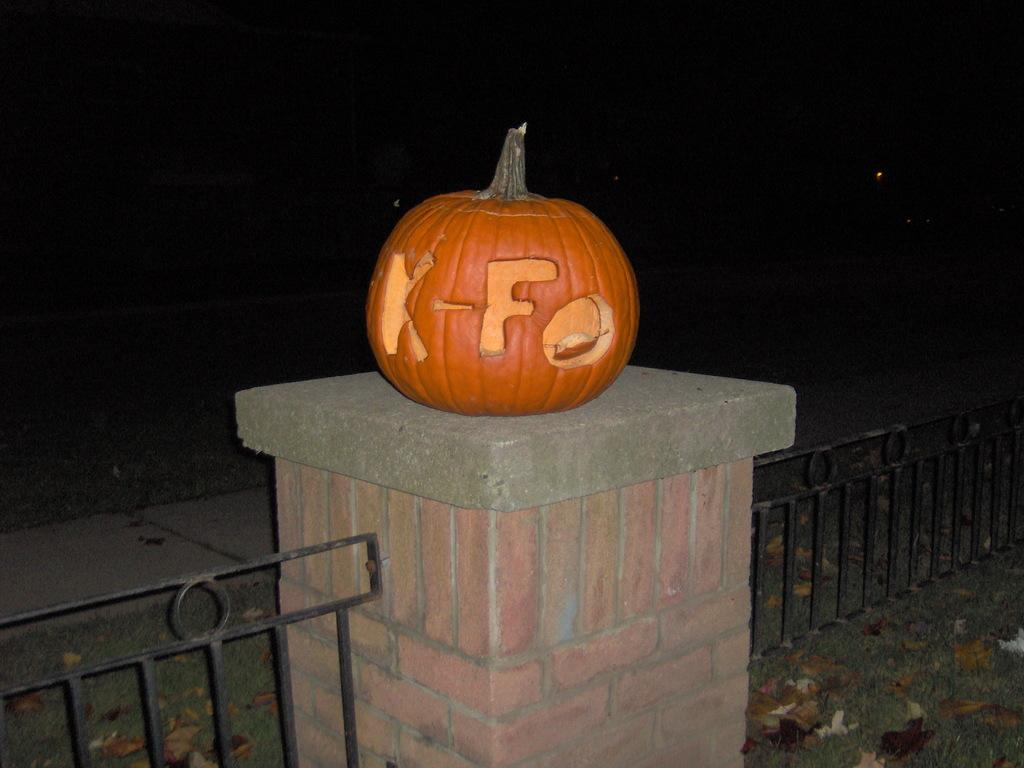What is located in the front of the image? There is a railing and a pillar in the front of the image. What is placed on the pillar? A pumpkin is placed on the pillar. What can be observed about the background of the image? The background of the image is dark. What is the membership rate for the club in the image? There is no club present in the image, so it is not possible to determine a membership rate. 